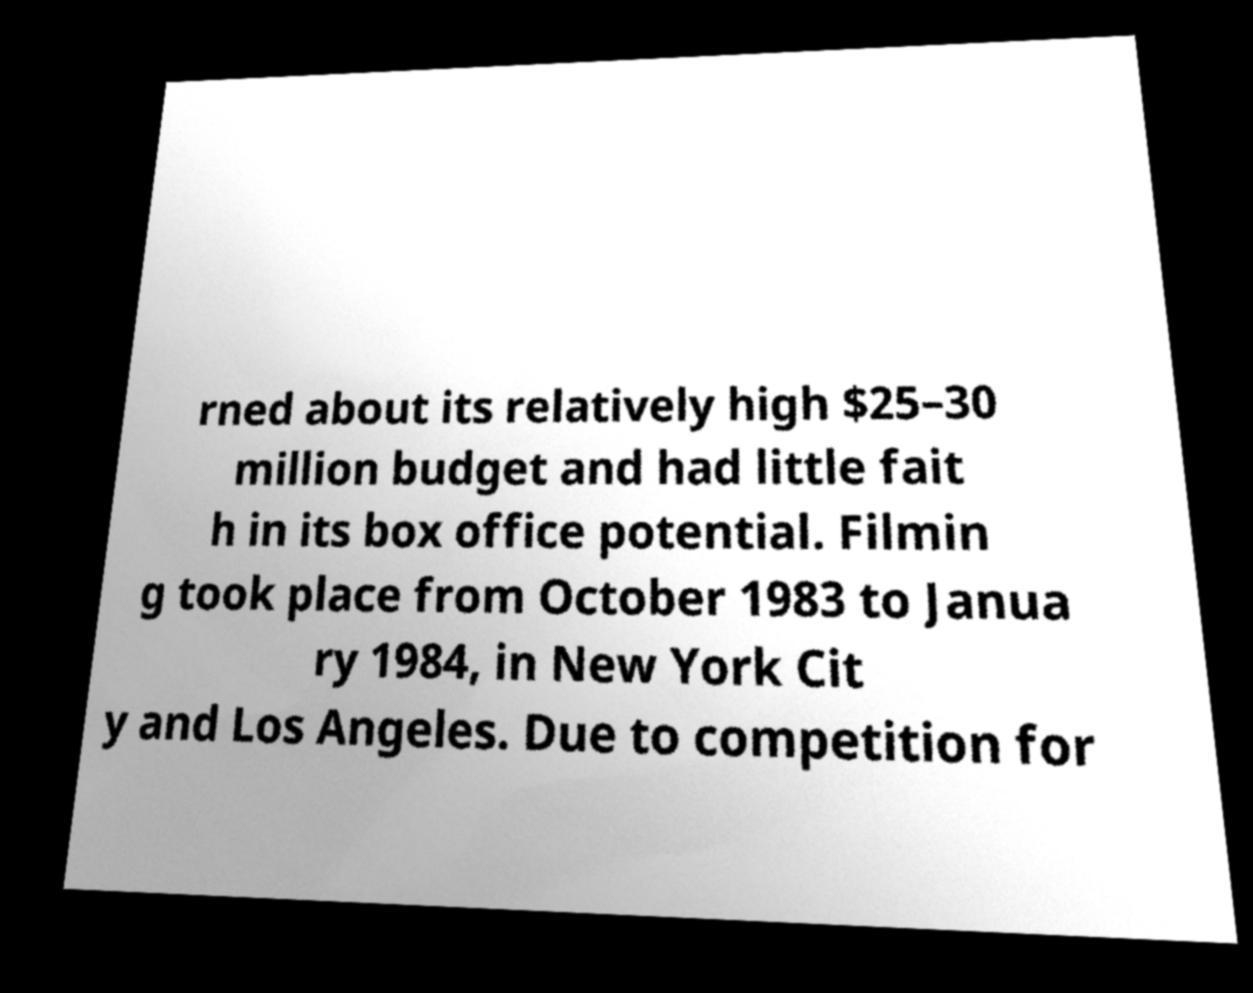Could you extract and type out the text from this image? rned about its relatively high $25–30 million budget and had little fait h in its box office potential. Filmin g took place from October 1983 to Janua ry 1984, in New York Cit y and Los Angeles. Due to competition for 